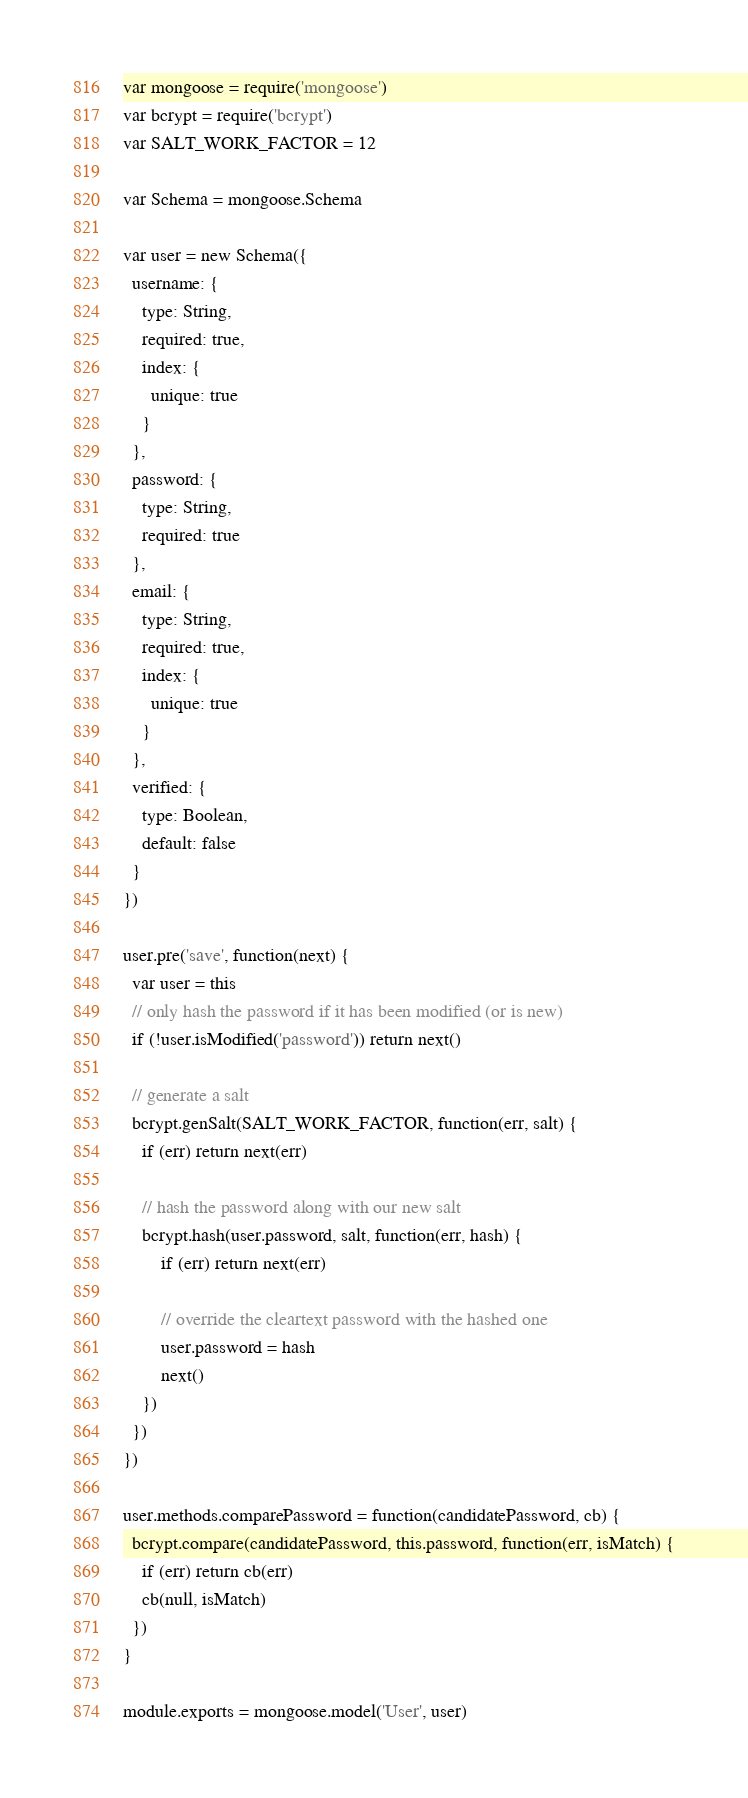Convert code to text. <code><loc_0><loc_0><loc_500><loc_500><_JavaScript_>var mongoose = require('mongoose')
var bcrypt = require('bcrypt')
var SALT_WORK_FACTOR = 12

var Schema = mongoose.Schema

var user = new Schema({
  username: {
    type: String,
    required: true,
    index: {
      unique: true
    }
  },
  password: {
    type: String,
    required: true
  },
  email: {
    type: String,
    required: true,
    index: {
      unique: true
    }
  },
  verified: {
    type: Boolean,
    default: false
  }
})

user.pre('save', function(next) { 
  var user = this
  // only hash the password if it has been modified (or is new)
  if (!user.isModified('password')) return next()

  // generate a salt
  bcrypt.genSalt(SALT_WORK_FACTOR, function(err, salt) {
    if (err) return next(err)

    // hash the password along with our new salt
    bcrypt.hash(user.password, salt, function(err, hash) {
        if (err) return next(err)

        // override the cleartext password with the hashed one
        user.password = hash
        next()
    })
  })
})

user.methods.comparePassword = function(candidatePassword, cb) {
  bcrypt.compare(candidatePassword, this.password, function(err, isMatch) {
    if (err) return cb(err)
    cb(null, isMatch)
  })
}

module.exports = mongoose.model('User', user)
</code> 